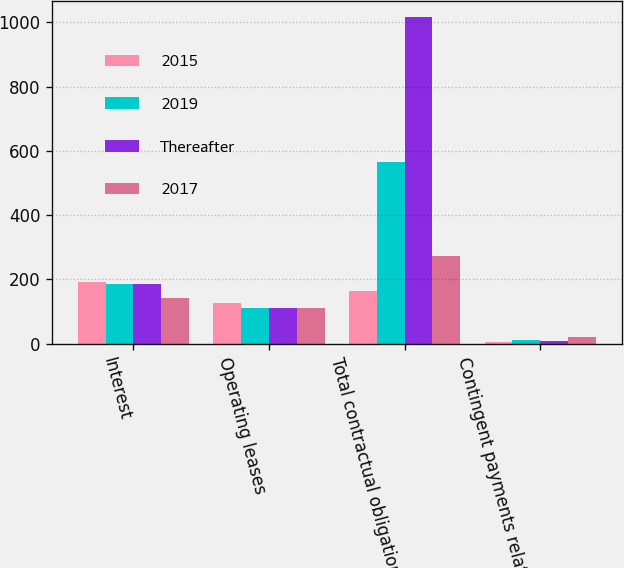Convert chart. <chart><loc_0><loc_0><loc_500><loc_500><stacked_bar_chart><ecel><fcel>Interest<fcel>Operating leases<fcel>Total contractual obligations<fcel>Contingent payments related to<nl><fcel>2015<fcel>191<fcel>126<fcel>164<fcel>5<nl><fcel>2019<fcel>186<fcel>111<fcel>564<fcel>10<nl><fcel>Thereafter<fcel>186<fcel>112<fcel>1016<fcel>7<nl><fcel>2017<fcel>142<fcel>111<fcel>273<fcel>19<nl></chart> 